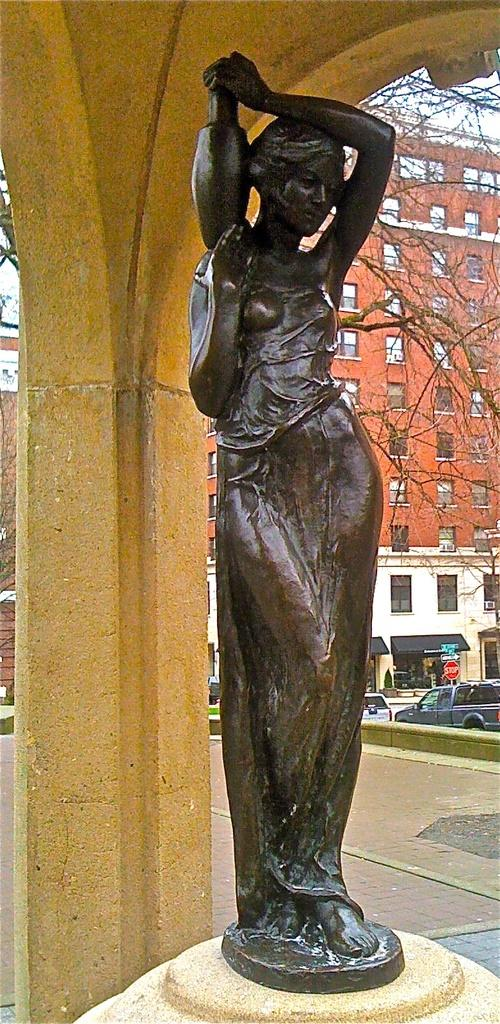What is the main subject in the image? There is a statue in the image. What else can be seen in the image besides the statue? There is a building and two cars in the image. Can you describe the building in the image? The building has boards on it. What type of gold jewelry is the woman wearing in the image? There is no woman or gold jewelry present in the image. 